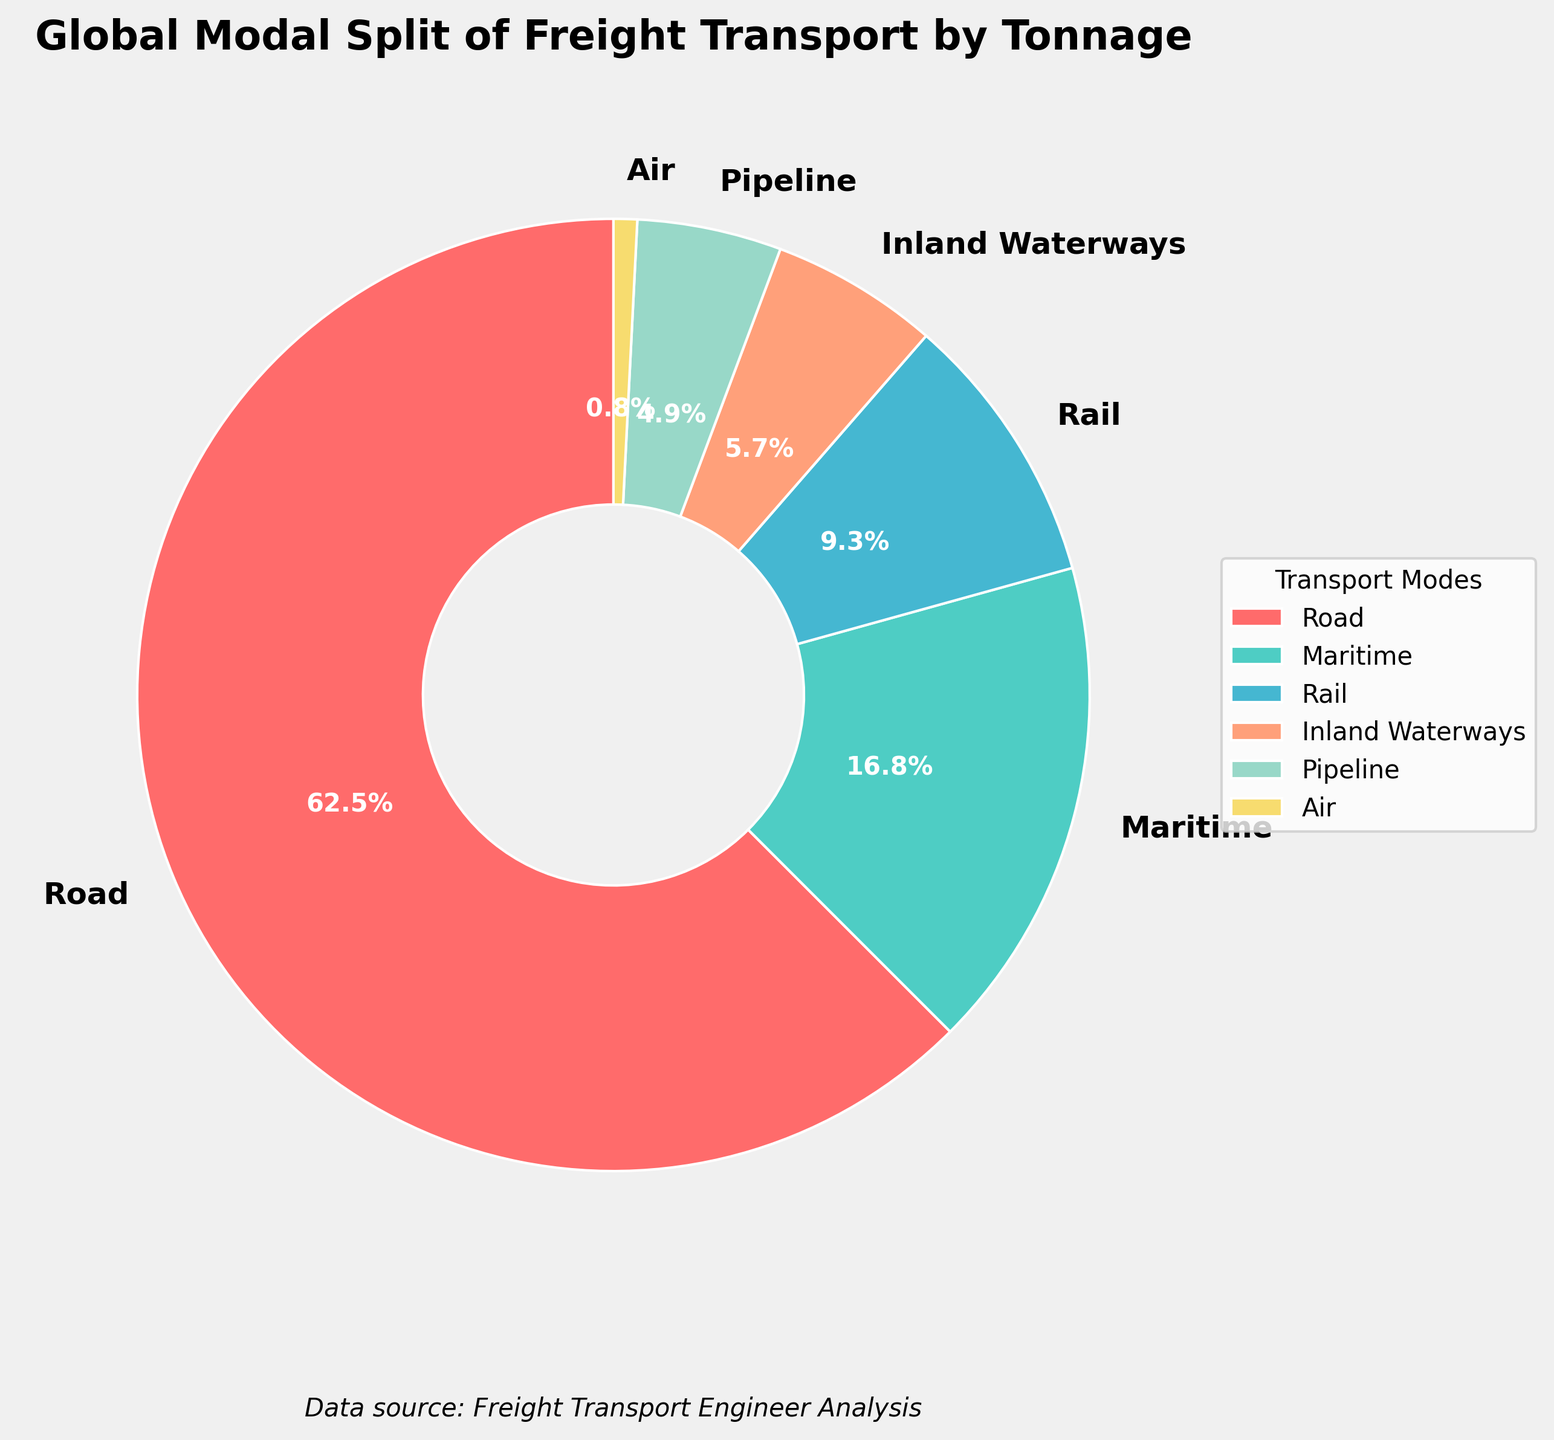Which transport mode has the highest percentage of global freight tonnage? The chart clearly shows that the "Road" transport mode occupies the largest segment of the pie chart. By looking at the labels, "Road" is listed with the highest percentage of 62.5%.
Answer: Road How much more freight tonnage does Maritime transport handle compared to Air transport? From the chart, Maritime transport handles 16.8% while Air transports 0.8%. Subtracting the Air transport percentage from the Maritime transport percentage gives the difference. (16.8% - 0.8%) = 16.0%
Answer: 16.0% What is the combined percentage of freight tonnage for Rail and Inland Waterways? Adding the percentage tonnage for Rail (9.3%) and Inland Waterways (5.7%) gives the combined percentage. (9.3% + 5.7%) = 15.0%
Answer: 15.0% Is the percentage of freight tonnage handled by Pipeline greater or less than Inland Waterways? The chart shows Inland Waterways at 5.7% and Pipeline at 4.9%. Comparing these two numbers, Pipeline is smaller than Inland Waterways.
Answer: Less What is the visual color of the segment representing Road transport? The chart indicates that the Road transport segment is represented in a red color.
Answer: Red Are the combined percentages of Air and Pipeline transport modes greater than that of Maritime transport? Summing the percentages for Air (0.8%) and Pipeline (4.9%) gives 5.7%. Comparing this sum with Maritime's 16.8%, the combined total is less.
Answer: No What is the difference in percentage points between the least used transport mode and the most used transport mode? The chart shows the least used mode is Air (0.8%) and the most used mode is Road (62.5%). Subtracting the smallest percentage from the largest gives the difference. (62.5% - 0.8%) = 61.7%
Answer: 61.7% Between Rail and Maritime, which transport mode handles more global freight tonnage, and by how much? Rail handles 9.3%, and Maritime handles 16.8%. Comparing these, Maritime handles more. The difference is calculated as (16.8% - 9.3%) = 7.5%
Answer: Maritime by 7.5% What is the percentage point difference between Inland Waterways and Pipeline transport modes? The chart shows Inland Waterways at 5.7% and Pipeline at 4.9%. The difference between these two percentages is (5.7% - 4.9%) = 0.8%
Answer: 0.8% 